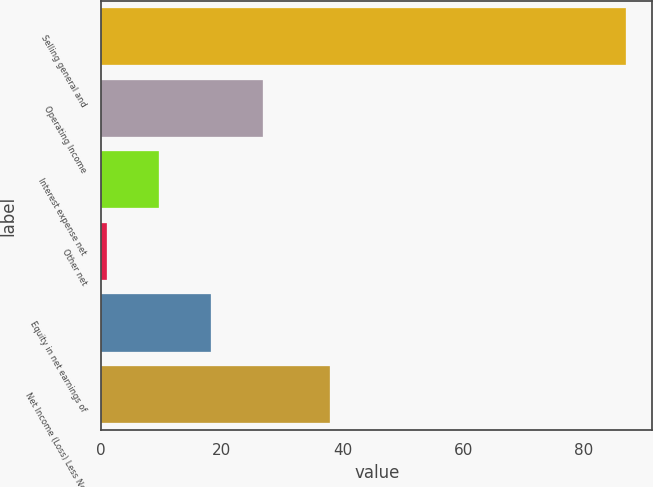Convert chart. <chart><loc_0><loc_0><loc_500><loc_500><bar_chart><fcel>Selling general and<fcel>Operating Income<fcel>Interest expense net<fcel>Other net<fcel>Equity in net earnings of<fcel>Net Income (Loss) Less Net<nl><fcel>87<fcel>26.8<fcel>9.6<fcel>1<fcel>18.2<fcel>38<nl></chart> 